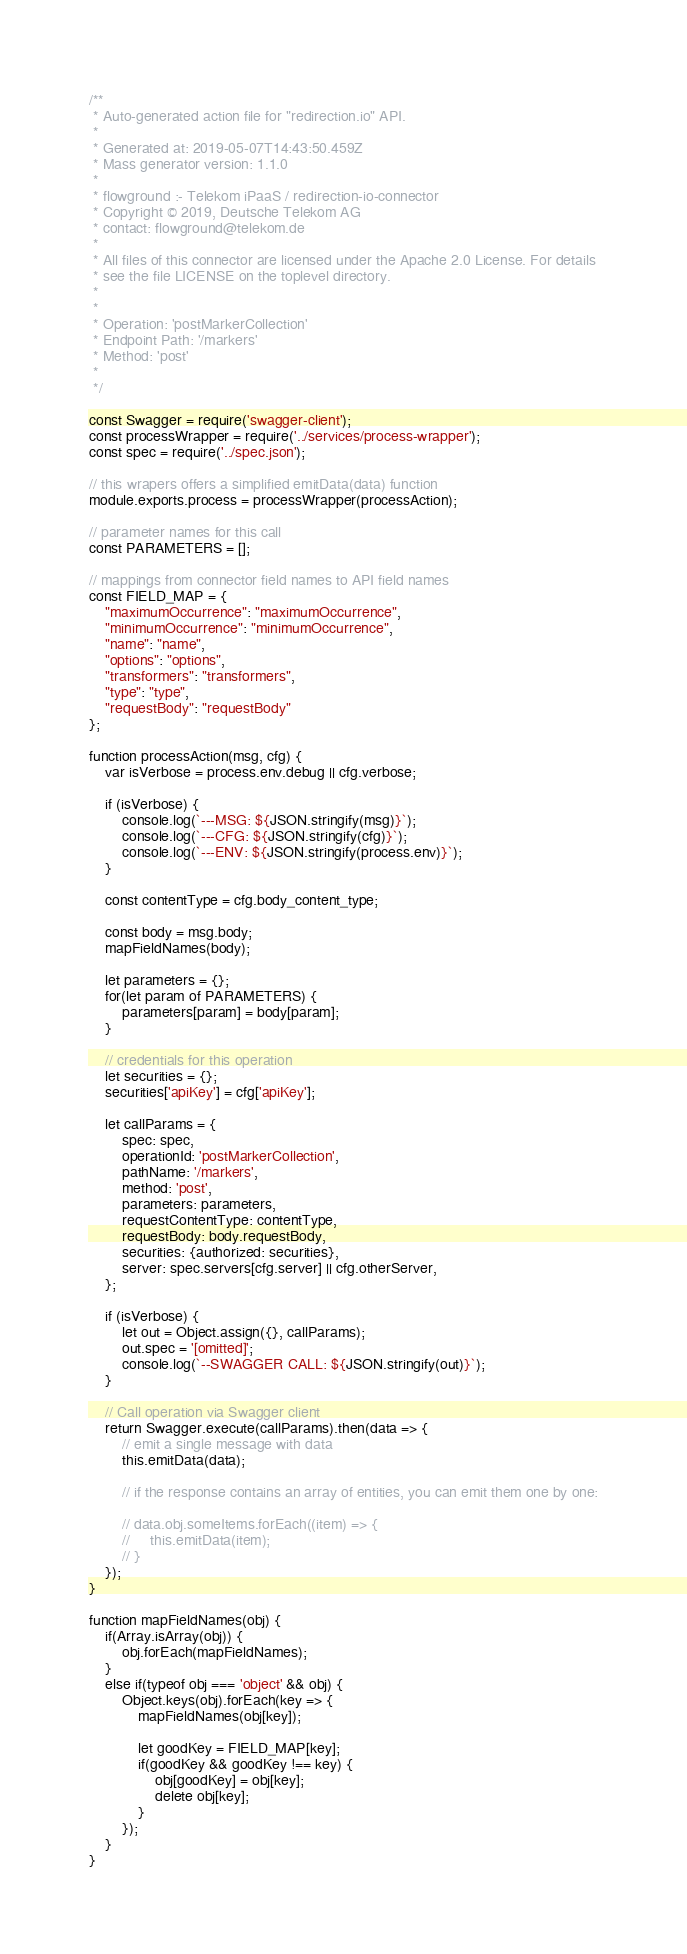<code> <loc_0><loc_0><loc_500><loc_500><_JavaScript_>/**
 * Auto-generated action file for "redirection.io" API.
 *
 * Generated at: 2019-05-07T14:43:50.459Z
 * Mass generator version: 1.1.0
 *
 * flowground :- Telekom iPaaS / redirection-io-connector
 * Copyright © 2019, Deutsche Telekom AG
 * contact: flowground@telekom.de
 *
 * All files of this connector are licensed under the Apache 2.0 License. For details
 * see the file LICENSE on the toplevel directory.
 *
 *
 * Operation: 'postMarkerCollection'
 * Endpoint Path: '/markers'
 * Method: 'post'
 *
 */

const Swagger = require('swagger-client');
const processWrapper = require('../services/process-wrapper');
const spec = require('../spec.json');

// this wrapers offers a simplified emitData(data) function
module.exports.process = processWrapper(processAction);

// parameter names for this call
const PARAMETERS = [];

// mappings from connector field names to API field names
const FIELD_MAP = {
    "maximumOccurrence": "maximumOccurrence",
    "minimumOccurrence": "minimumOccurrence",
    "name": "name",
    "options": "options",
    "transformers": "transformers",
    "type": "type",
    "requestBody": "requestBody"
};

function processAction(msg, cfg) {
    var isVerbose = process.env.debug || cfg.verbose;

    if (isVerbose) {
        console.log(`---MSG: ${JSON.stringify(msg)}`);
        console.log(`---CFG: ${JSON.stringify(cfg)}`);
        console.log(`---ENV: ${JSON.stringify(process.env)}`);
    }

    const contentType = cfg.body_content_type;

    const body = msg.body;
    mapFieldNames(body);

    let parameters = {};
    for(let param of PARAMETERS) {
        parameters[param] = body[param];
    }

    // credentials for this operation
    let securities = {};
    securities['apiKey'] = cfg['apiKey'];

    let callParams = {
        spec: spec,
        operationId: 'postMarkerCollection',
        pathName: '/markers',
        method: 'post',
        parameters: parameters,
        requestContentType: contentType,
        requestBody: body.requestBody,
        securities: {authorized: securities},
        server: spec.servers[cfg.server] || cfg.otherServer,
    };

    if (isVerbose) {
        let out = Object.assign({}, callParams);
        out.spec = '[omitted]';
        console.log(`--SWAGGER CALL: ${JSON.stringify(out)}`);
    }

    // Call operation via Swagger client
    return Swagger.execute(callParams).then(data => {
        // emit a single message with data
        this.emitData(data);

        // if the response contains an array of entities, you can emit them one by one:

        // data.obj.someItems.forEach((item) => {
        //     this.emitData(item);
        // }
    });
}

function mapFieldNames(obj) {
    if(Array.isArray(obj)) {
        obj.forEach(mapFieldNames);
    }
    else if(typeof obj === 'object' && obj) {
        Object.keys(obj).forEach(key => {
            mapFieldNames(obj[key]);

            let goodKey = FIELD_MAP[key];
            if(goodKey && goodKey !== key) {
                obj[goodKey] = obj[key];
                delete obj[key];
            }
        });
    }
}</code> 